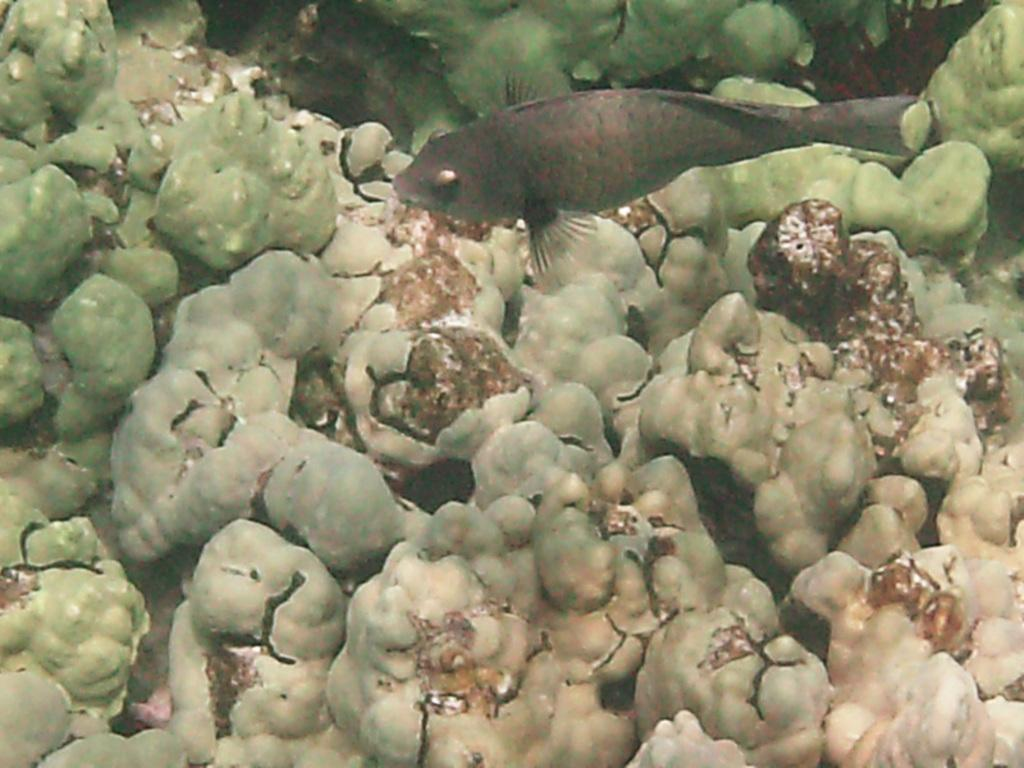What type of environment is depicted in the image? The image is an underwater picture. What type of animal can be seen in the image? There is a fish in the image. What colors are present on the fish? The fish is grey and black in color. What other objects are present in the image besides the fish? There are other objects in the image that are green, cream, and brown in color. What type of trick does the fish perform in the image? There is no trick being performed by the fish in the image; it is simply swimming. 